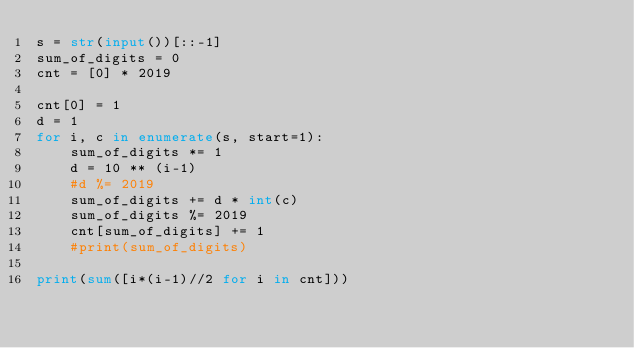Convert code to text. <code><loc_0><loc_0><loc_500><loc_500><_Python_>s = str(input())[::-1]
sum_of_digits = 0
cnt = [0] * 2019

cnt[0] = 1
d = 1
for i, c in enumerate(s, start=1):
    sum_of_digits *= 1
    d = 10 ** (i-1)
    #d %= 2019
    sum_of_digits += d * int(c)
    sum_of_digits %= 2019
    cnt[sum_of_digits] += 1
    #print(sum_of_digits)

print(sum([i*(i-1)//2 for i in cnt]))</code> 